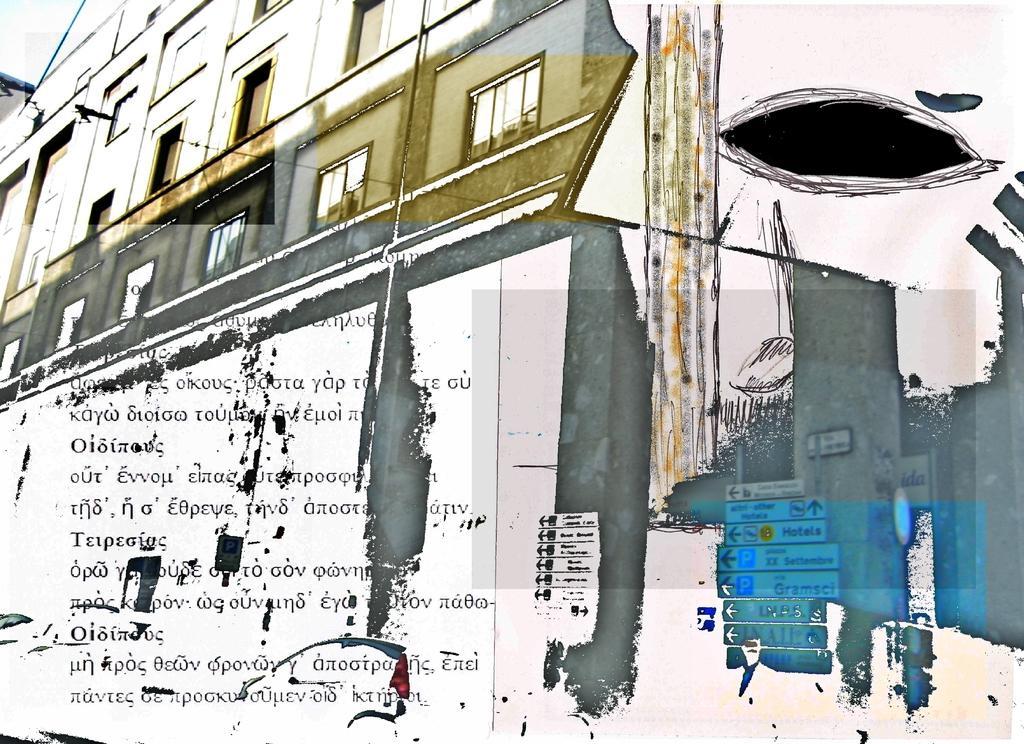In one or two sentences, can you explain what this image depicts? In this picture there is a building and there is something written below it and there are some other objects in the right corner. 